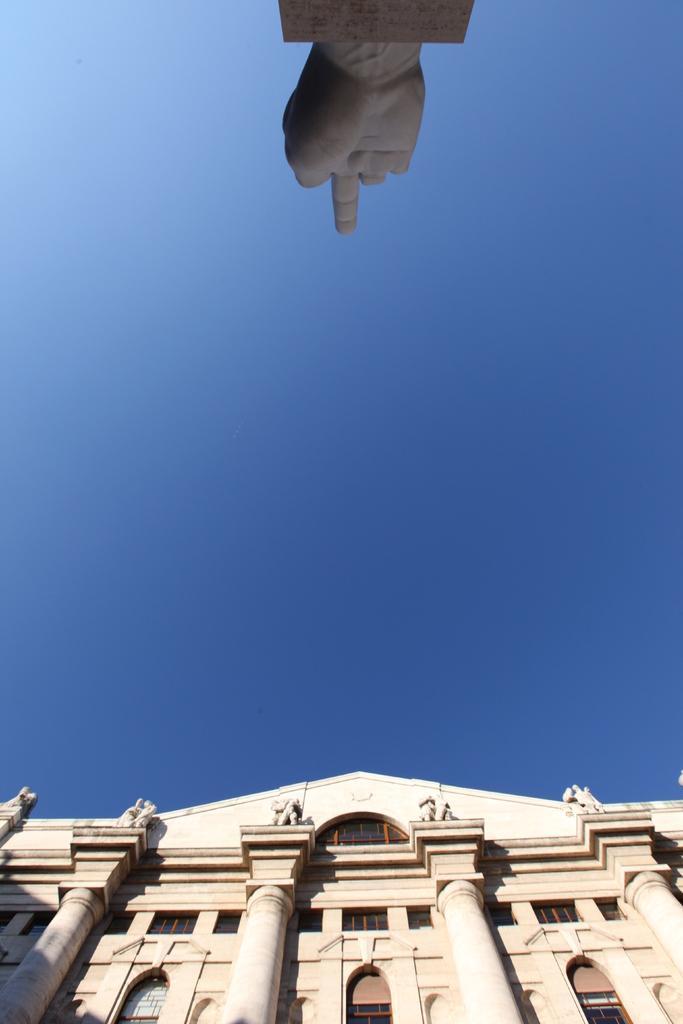How would you summarize this image in a sentence or two? In this image there is a building, at the top of the image there is a structure of the hand. 